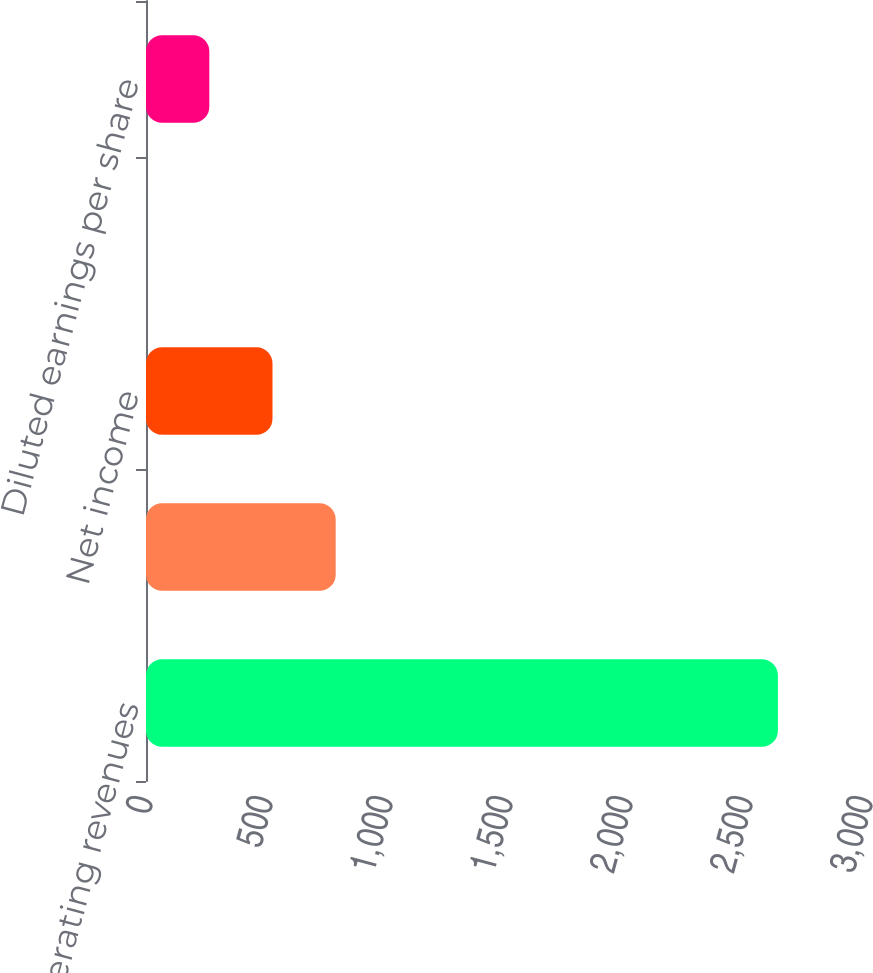<chart> <loc_0><loc_0><loc_500><loc_500><bar_chart><fcel>Operating revenues<fcel>Operating income (a)<fcel>Net income<fcel>Basic earnings per share<fcel>Diluted earnings per share<nl><fcel>2633<fcel>790.29<fcel>527.05<fcel>0.57<fcel>263.81<nl></chart> 